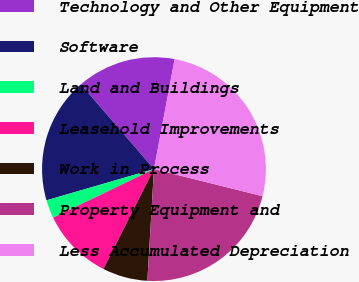Convert chart. <chart><loc_0><loc_0><loc_500><loc_500><pie_chart><fcel>Technology and Other Equipment<fcel>Software<fcel>Land and Buildings<fcel>Leasehold Improvements<fcel>Work in Process<fcel>Property Equipment and<fcel>Less Accumulated Depreciation<nl><fcel>14.29%<fcel>18.17%<fcel>2.64%<fcel>10.4%<fcel>6.52%<fcel>22.05%<fcel>25.93%<nl></chart> 